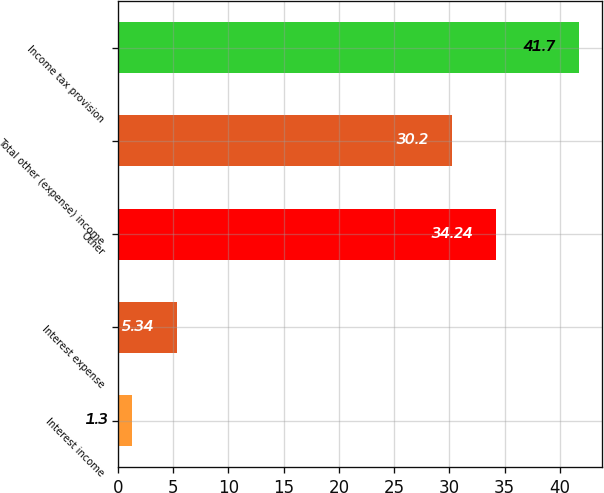Convert chart to OTSL. <chart><loc_0><loc_0><loc_500><loc_500><bar_chart><fcel>Interest income<fcel>Interest expense<fcel>Other<fcel>Total other (expense) income<fcel>Income tax provision<nl><fcel>1.3<fcel>5.34<fcel>34.24<fcel>30.2<fcel>41.7<nl></chart> 